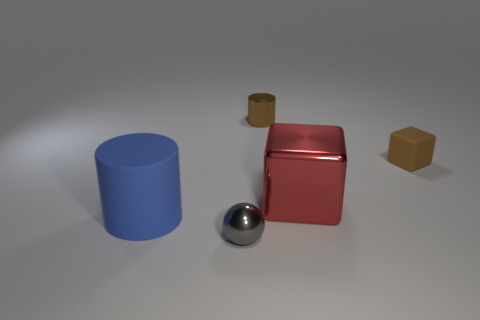How would you describe the mood of this image based on the use of colors? The use of muted colors and the cool tone of the blue cylinder contribute to a calm and serene mood, which is further reinforced by the clean, uncluttered composition of the objects within the space. What do the different colors and materials of the objects suggest about contrast in this image? The contrast in colors and materials highlights the individual characteristics of each object, with the reflective metal sphere, the matte plastic of the cube and cylinder, and the muted gold of the smaller cylinder standing out distinctly against one another. 